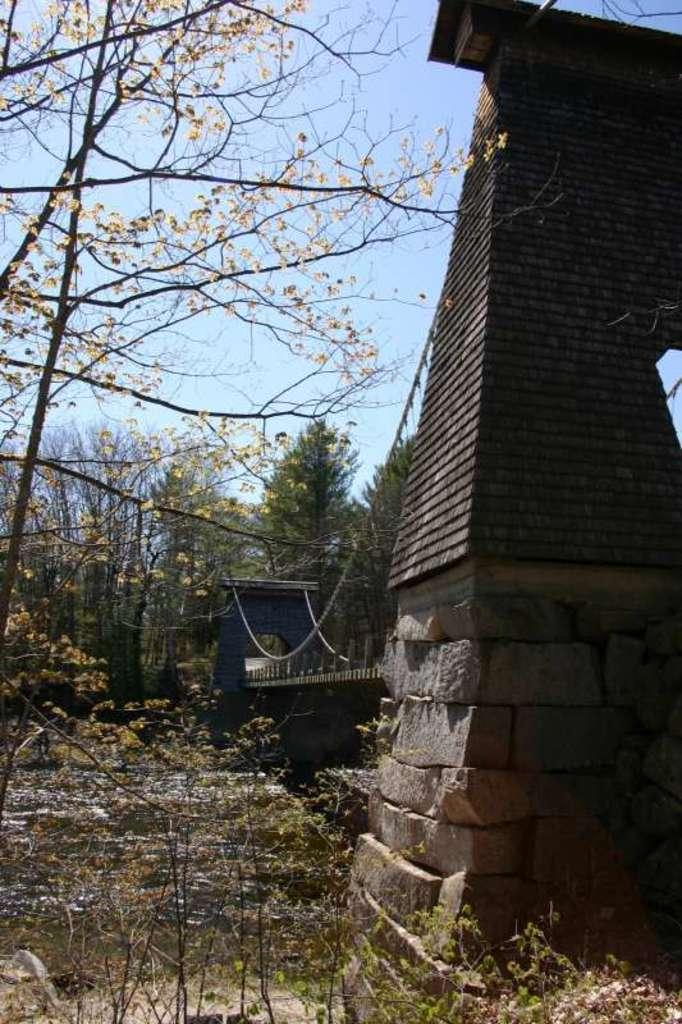Describe this image in one or two sentences. There is a bridge in the right corner and there are water under it and there are trees in the background. 